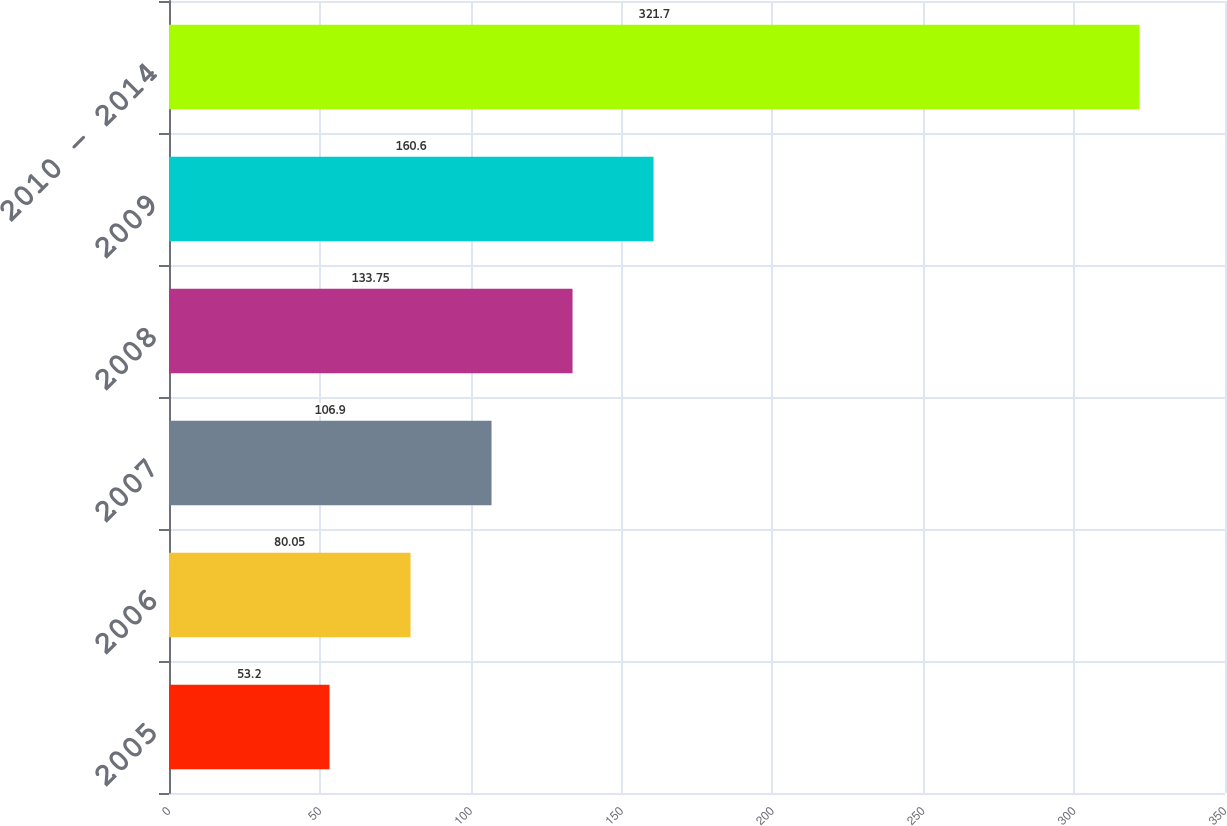<chart> <loc_0><loc_0><loc_500><loc_500><bar_chart><fcel>2005<fcel>2006<fcel>2007<fcel>2008<fcel>2009<fcel>2010 - 2014<nl><fcel>53.2<fcel>80.05<fcel>106.9<fcel>133.75<fcel>160.6<fcel>321.7<nl></chart> 